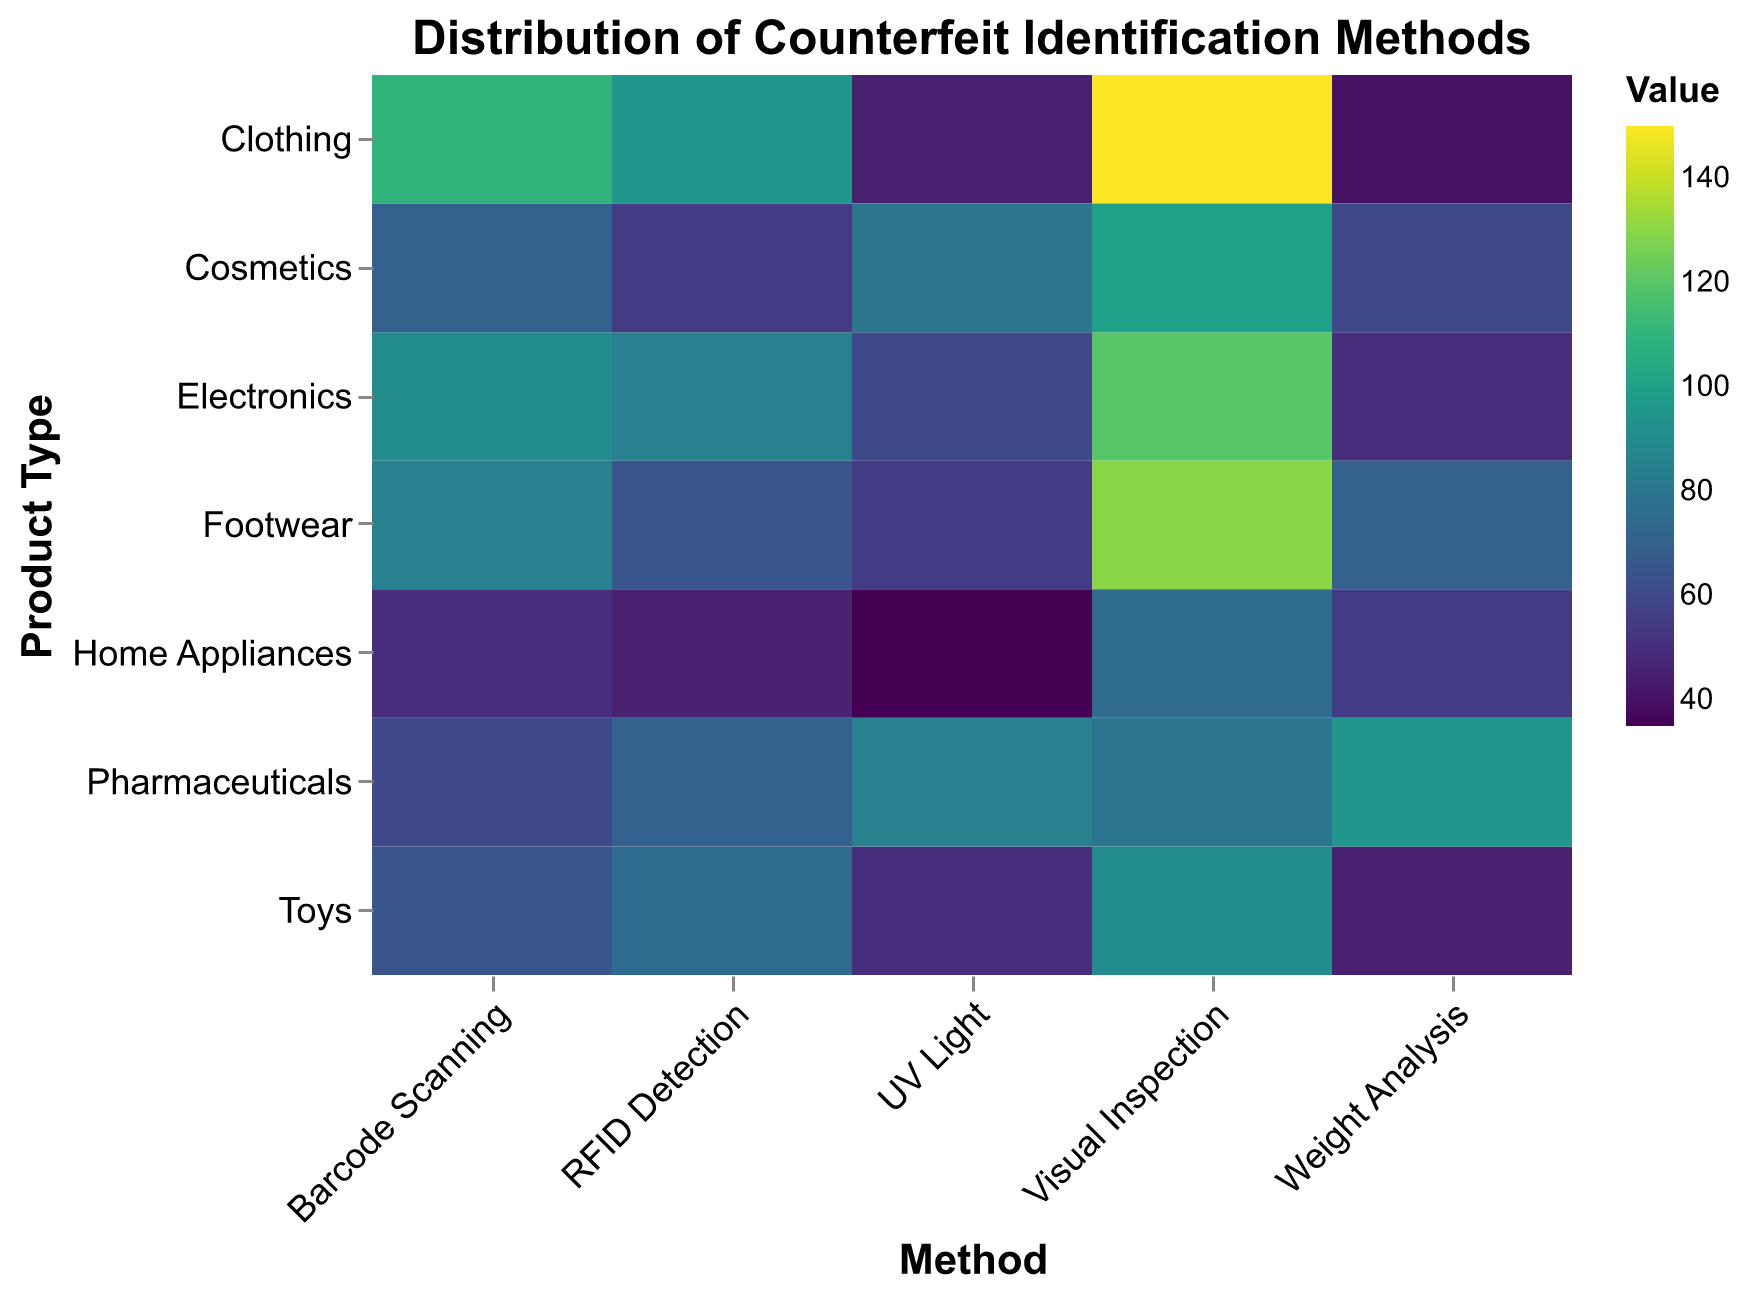What is the title of the figure? Look at the top of the figure where the title is placed. The text there will give the title.
Answer: Distribution of Counterfeit Identification Methods Which product type has the highest value for Visual Inspection? Scan across the row for "Visual Inspection" and identify the highest numerical value among the product types, then note the corresponding product type.
Answer: Clothing Which method has the least variation in values across all product types? To determine this, observe the range of values (lowest to highest) across each method and find the one with the smallest range. Barcode Scanning and RFID Detection both show the least variation but Barcode Scanning is slightly more consistent.
Answer: Barcode Scanning Which product type utilizes Weight Analysis the most for counterfeit identification? Check the row corresponding to "Weight Analysis" and find the highest value. Then, identify the product type associated with this value.
Answer: Pharmaceuticals Which product type is least associated with "UV Light" detection, and what is the corresponding value? Look at the values in the "UV Light" column and find the lowest one, then match it with the product type.
Answer: Home Appliances, 35 Compare the use of Barcode Scanning in Electronics and Footwear. Which one is higher and by how much? Look at the values of Barcode Scanning for both Electronics and Footwear, then calculate the difference. 90 (Electronics) and 85 (Footwear) lead to:
90 - 85 = 5
Answer: Electronics by 5 Is there any method where no product type exceeds a value of 100? Check all methods to verify if there's any with all values ≤ 100. All methods like Barcode Scanning, RFID Detection, UV Light, and Weight Analysis have at least one product type with value > 100. Only UV Light stays within limits ≤ 100 for all product types.
Answer: No In which detection method are Toys detected second most often, and what is the corresponding value? Examine the values corresponding to the "Toys" row and find the second highest value, along with the method. The values for Toys: 90 (Visual Inspection), 65 (Barcode Scanning), 75 (RFID Detection), 50 (UV Light), 45 (Weight Analysis). So, RFID Detection is the second highest.
Answer: RFID Detection, 75 